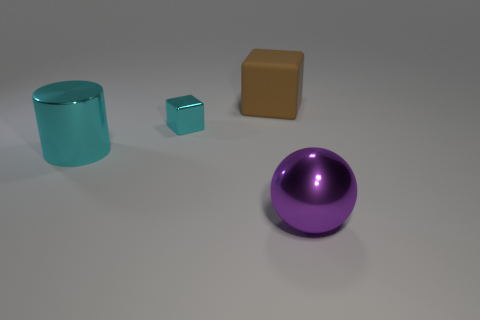Add 1 balls. How many objects exist? 5 Subtract all cylinders. How many objects are left? 3 Subtract 0 purple cubes. How many objects are left? 4 Subtract all shiny balls. Subtract all cylinders. How many objects are left? 2 Add 1 large rubber blocks. How many large rubber blocks are left? 2 Add 3 purple metallic blocks. How many purple metallic blocks exist? 3 